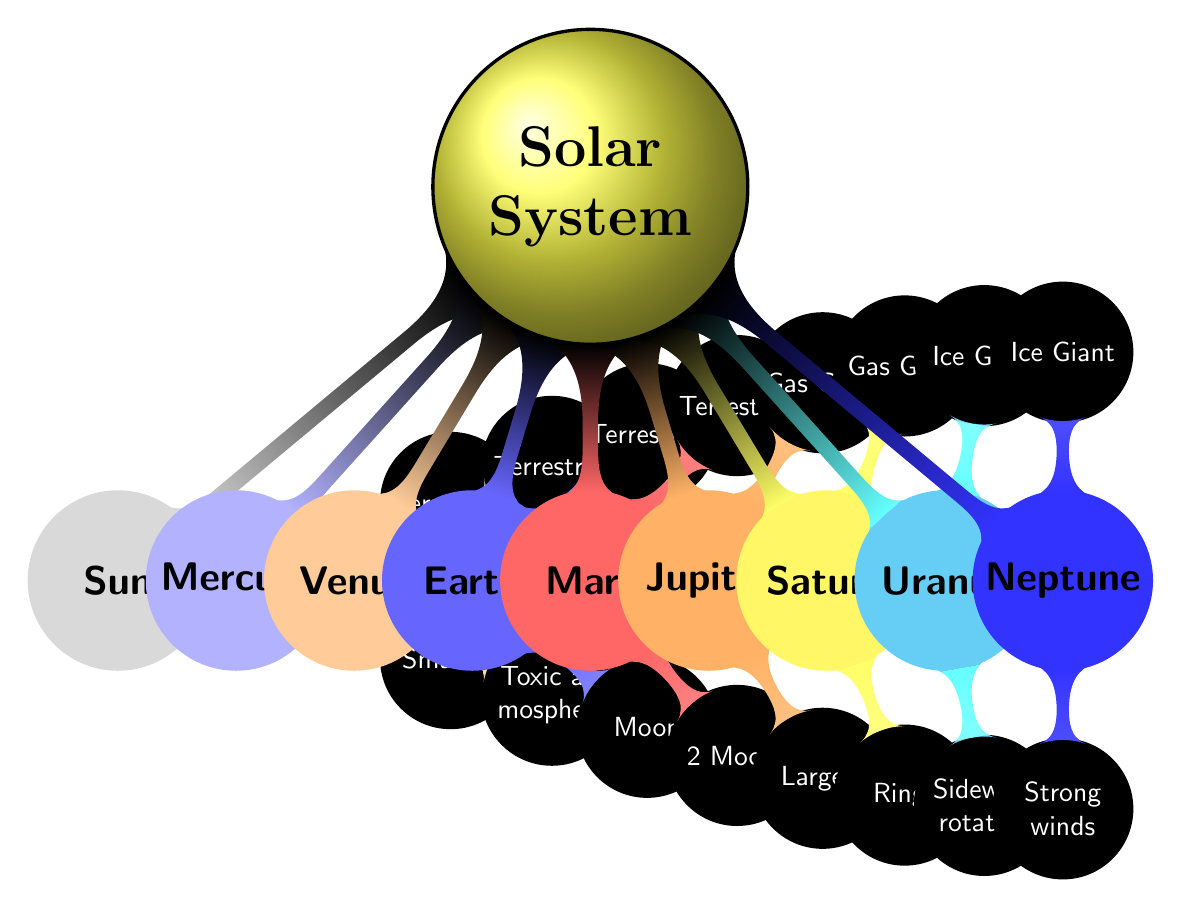What is the type of Jupiter? The diagram indicates that Jupiter is classified as a "Gas Giant." You can determine this by looking at the node labeled Jupiter and reading the corresponding characteristics.
Answer: Gas Giant How many moons does Earth have? According to the diagram, the Earth node includes a mention of its moon, specifically labeled as "Moon." Therefore, Earth has one moon.
Answer: 1 What is a key characteristic of Saturn? The diagram lists key characteristics for Saturn, one of which is its "Ring system." This information can be found directly beneath the Saturn node.
Answer: Ring system Which planet has the thick toxic atmosphere? The diagram specifies that Venus is noted for having a "Thick toxic atmosphere." By reference to the node for Venus, this information is clear.
Answer: Venus Name two moons of Mars. The node for Mars specifically includes the names of its moons: "Phobos" and "Deimos." By checking the Mars node, you can find these two names listed.
Answer: Phobos, Deimos Which planet is known as the "Red planet"? The diagram states that Mars is described as the "Red planet." This characteristic can be found under the Mars node, connecting its identity to this color description.
Answer: Mars What unique rotation characteristic does Uranus exhibit? The diagram mentions that Uranus has a "Sideways rotation." This is highlighted in the characteristics listed beneath the Uranus node, indicating its distinctive rotational behavior.
Answer: Sideways rotation How many planets are classified as Terrestrial? By reviewing the diagram, you can see that Mercury, Venus, Earth, and Mars are all categorized as Terrestrial. Counting these nodes gives us four planets of this type.
Answer: 4 